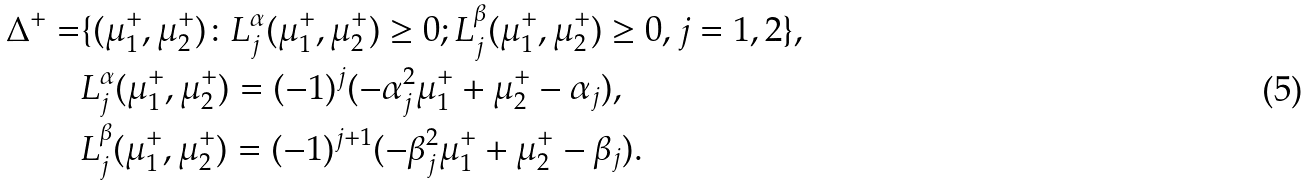<formula> <loc_0><loc_0><loc_500><loc_500>\Delta ^ { + } = & \{ ( \mu _ { 1 } ^ { + } , \mu _ { 2 } ^ { + } ) \colon L _ { j } ^ { \alpha } ( \mu _ { 1 } ^ { + } , \mu _ { 2 } ^ { + } ) \geq 0 ; L _ { j } ^ { \beta } ( \mu _ { 1 } ^ { + } , \mu _ { 2 } ^ { + } ) \geq 0 , j = 1 , 2 \} , \\ & L _ { j } ^ { \alpha } ( \mu _ { 1 } ^ { + } , \mu _ { 2 } ^ { + } ) = ( - 1 ) ^ { j } ( - \alpha _ { j } ^ { 2 } \mu _ { 1 } ^ { + } + \mu _ { 2 } ^ { + } - \alpha _ { j } ) , \\ & L _ { j } ^ { \beta } ( \mu _ { 1 } ^ { + } , \mu _ { 2 } ^ { + } ) = ( - 1 ) ^ { j + 1 } ( - \beta _ { j } ^ { 2 } \mu _ { 1 } ^ { + } + \mu _ { 2 } ^ { + } - \beta _ { j } ) .</formula> 